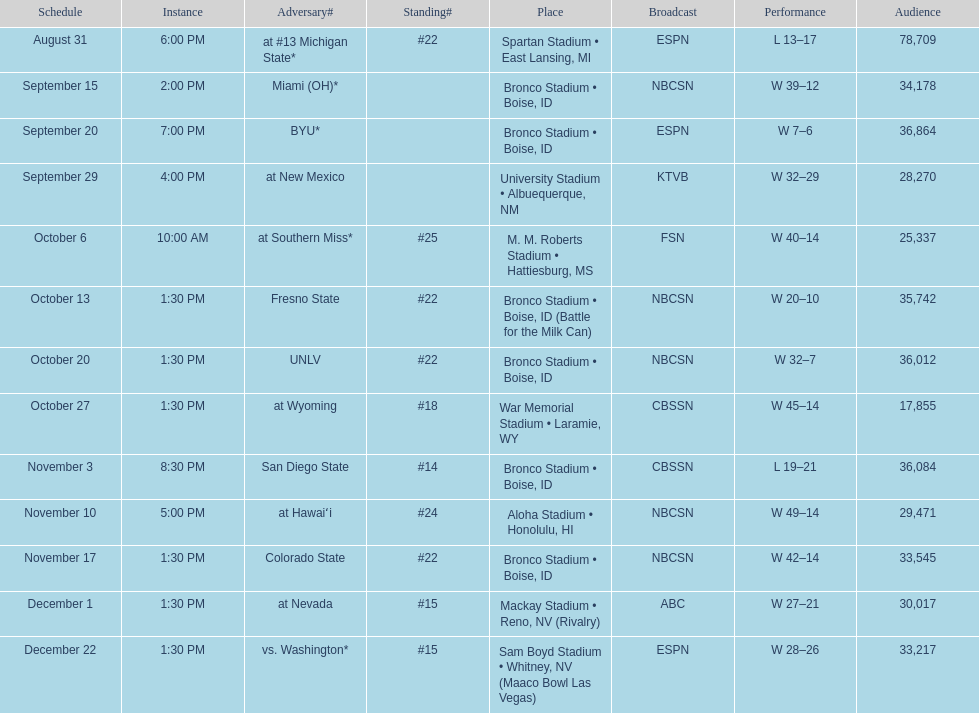What is the score difference for the game against michigan state? 4. 